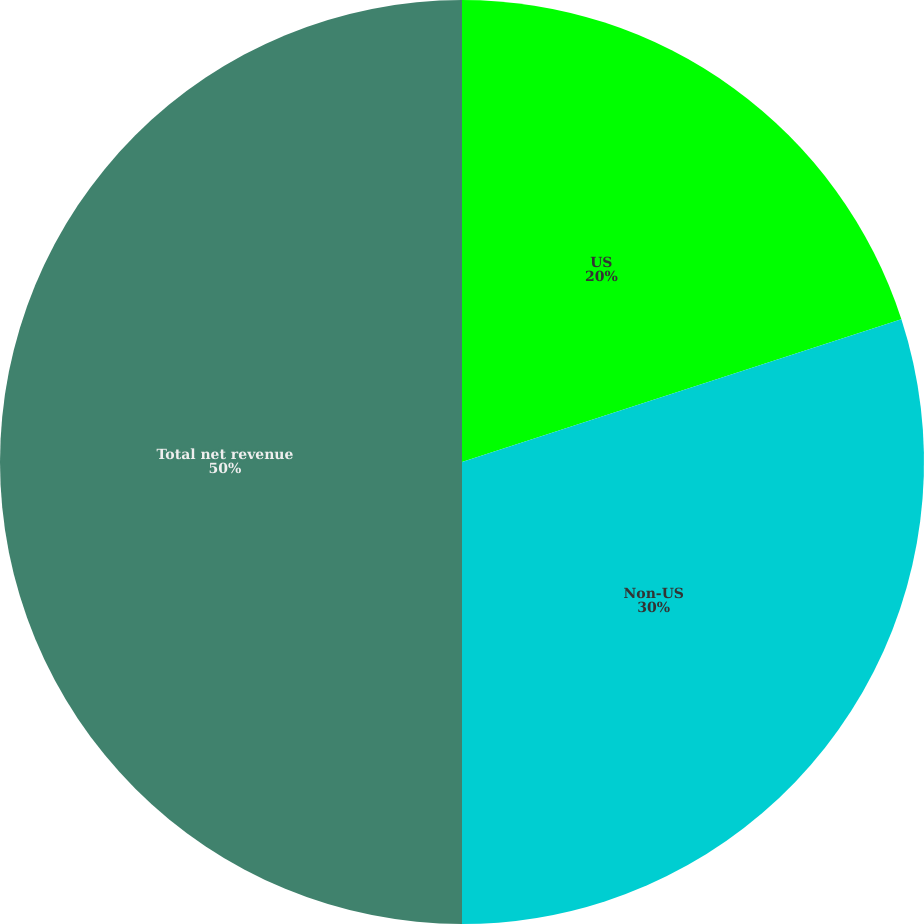<chart> <loc_0><loc_0><loc_500><loc_500><pie_chart><fcel>US<fcel>Non-US<fcel>Total net revenue<nl><fcel>20.0%<fcel>30.0%<fcel>50.0%<nl></chart> 